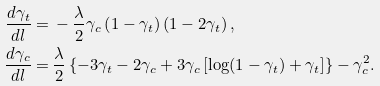Convert formula to latex. <formula><loc_0><loc_0><loc_500><loc_500>\frac { d \gamma _ { t } } { d l } = & \, - \frac { \lambda } { 2 } \gamma _ { c } \left ( 1 - \gamma _ { t } \right ) \left ( 1 - 2 \gamma _ { t } \right ) , \\ \frac { d \gamma _ { c } } { d l } = & \, \frac { \lambda } { 2 } \left \{ - 3 \gamma _ { t } - 2 \gamma _ { c } + 3 \gamma _ { c } \left [ \log ( 1 - \gamma _ { t } ) + \gamma _ { t } \right ] \right \} - \gamma _ { c } ^ { 2 } .</formula> 